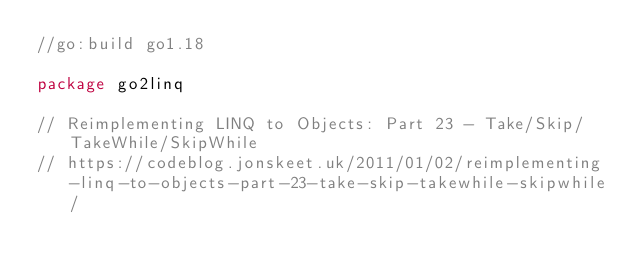<code> <loc_0><loc_0><loc_500><loc_500><_Go_>//go:build go1.18

package go2linq

// Reimplementing LINQ to Objects: Part 23 - Take/Skip/TakeWhile/SkipWhile
// https://codeblog.jonskeet.uk/2011/01/02/reimplementing-linq-to-objects-part-23-take-skip-takewhile-skipwhile/</code> 